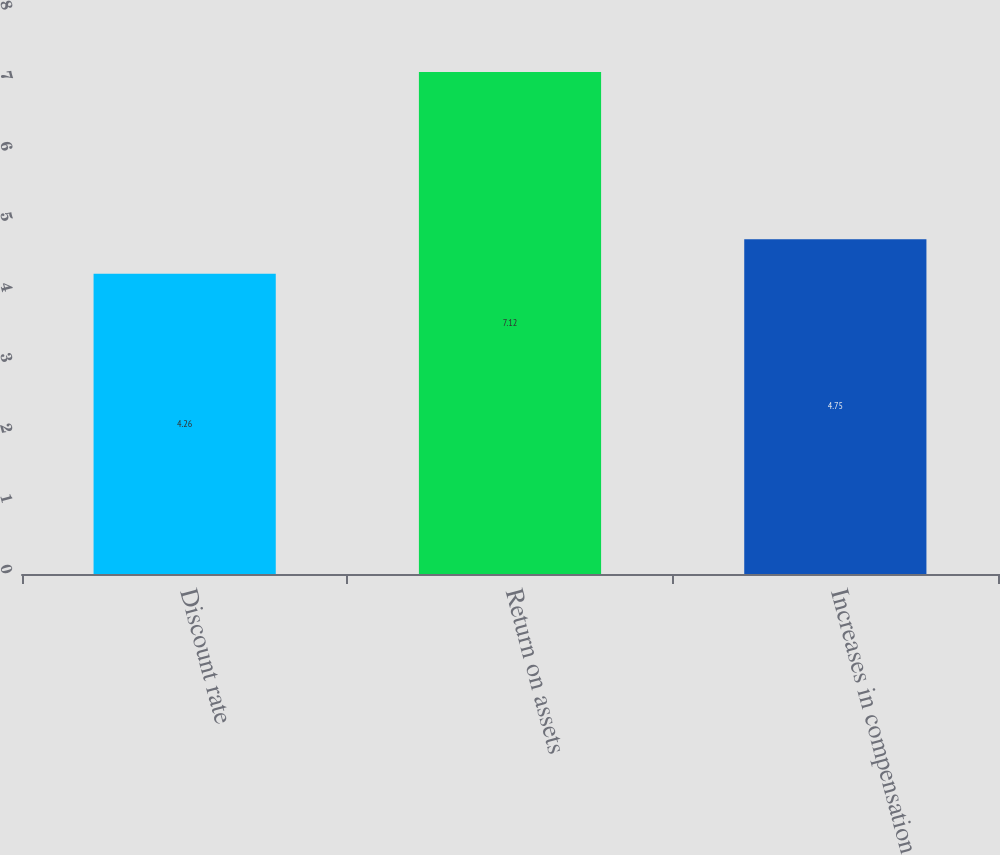Convert chart. <chart><loc_0><loc_0><loc_500><loc_500><bar_chart><fcel>Discount rate<fcel>Return on assets<fcel>Increases in compensation<nl><fcel>4.26<fcel>7.12<fcel>4.75<nl></chart> 